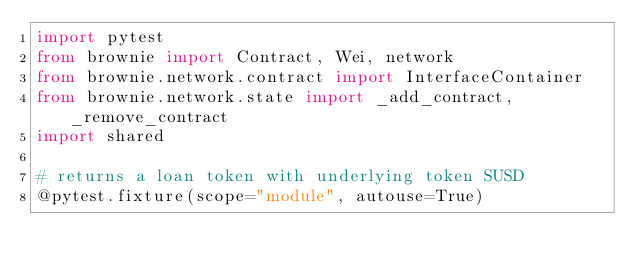Convert code to text. <code><loc_0><loc_0><loc_500><loc_500><_Python_>import pytest
from brownie import Contract, Wei, network
from brownie.network.contract import InterfaceContainer
from brownie.network.state import _add_contract, _remove_contract
import shared

# returns a loan token with underlying token SUSD  
@pytest.fixture(scope="module", autouse=True)</code> 